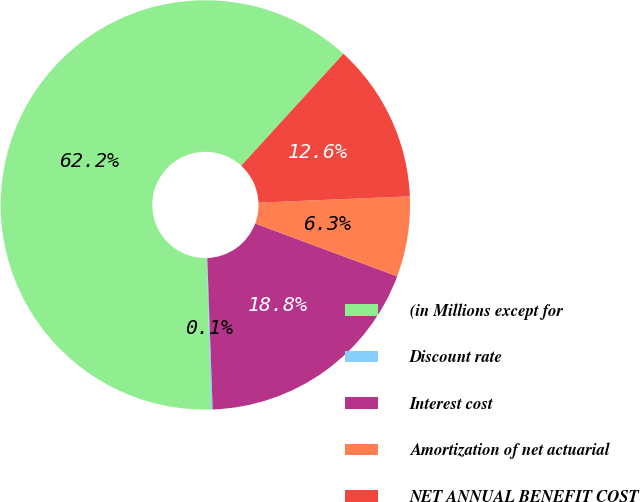Convert chart. <chart><loc_0><loc_0><loc_500><loc_500><pie_chart><fcel>(in Millions except for<fcel>Discount rate<fcel>Interest cost<fcel>Amortization of net actuarial<fcel>NET ANNUAL BENEFIT COST<nl><fcel>62.22%<fcel>0.13%<fcel>18.76%<fcel>6.34%<fcel>12.55%<nl></chart> 